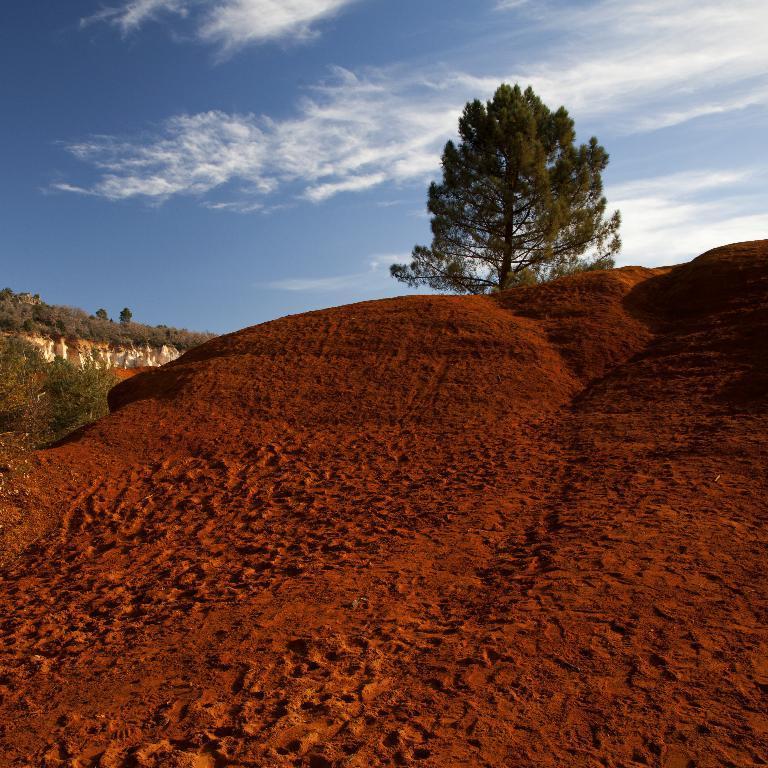In one or two sentences, can you explain what this image depicts? As we can see in the image there is sand, plants and trees. At the top there is sky and clouds. 